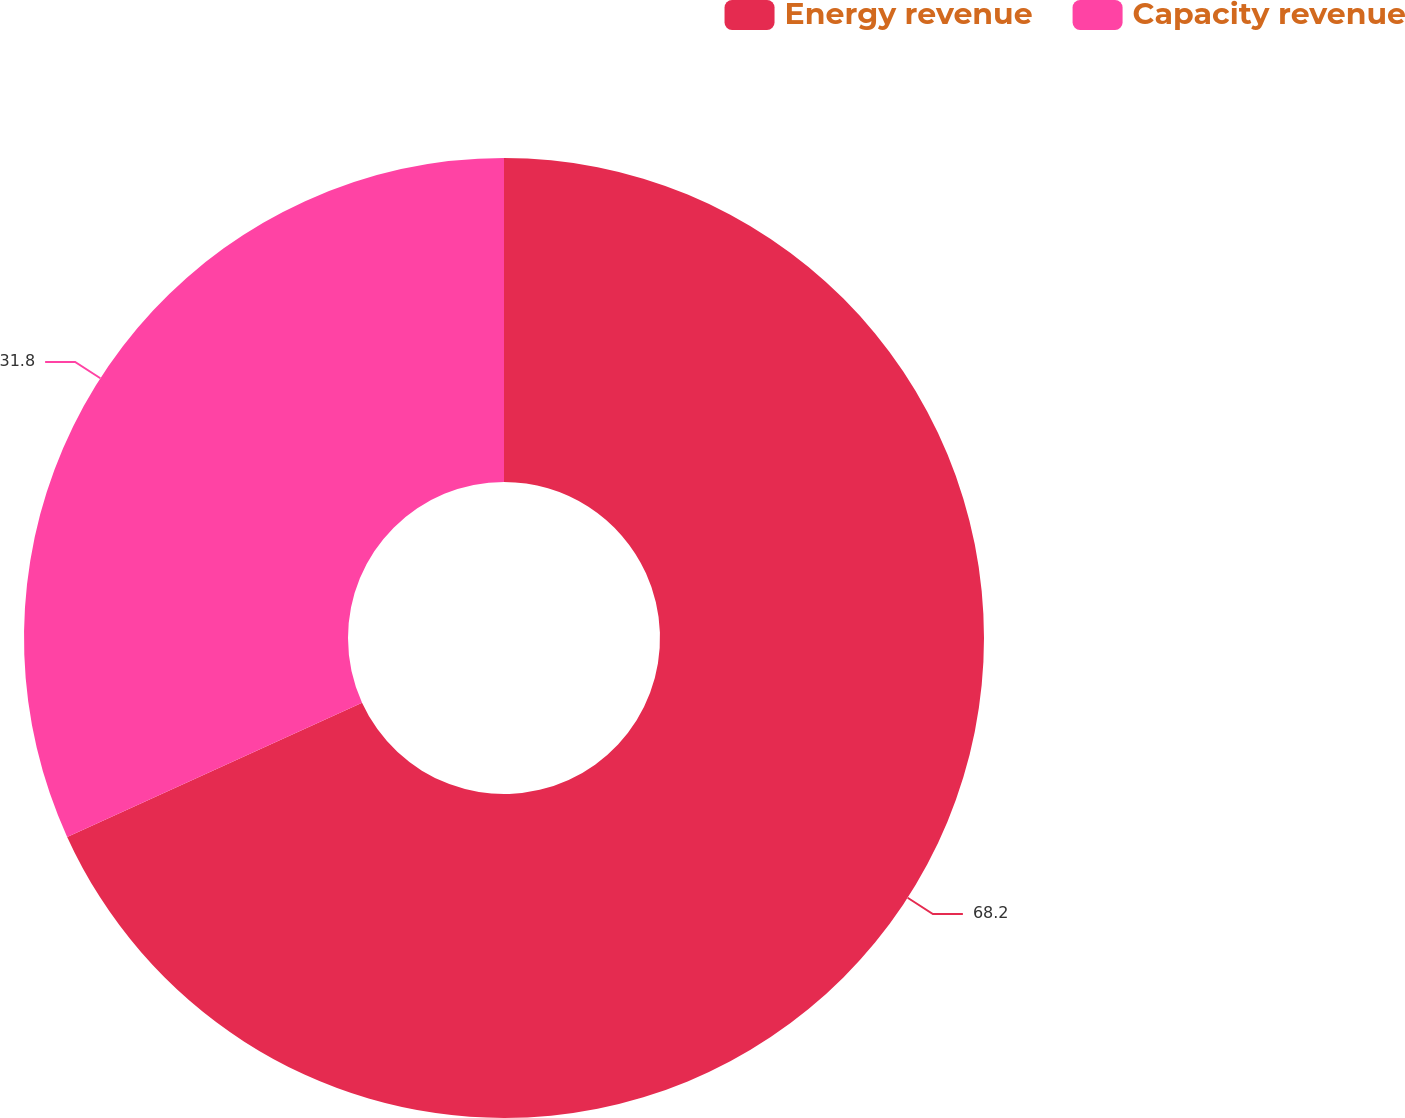<chart> <loc_0><loc_0><loc_500><loc_500><pie_chart><fcel>Energy revenue<fcel>Capacity revenue<nl><fcel>68.2%<fcel>31.8%<nl></chart> 